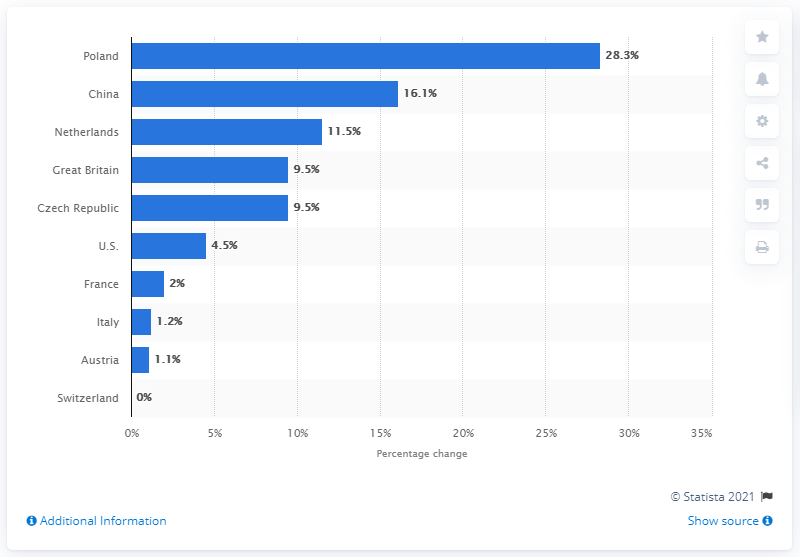List a handful of essential elements in this visual. In 2014, the year-on-year change in German electronics exports to the Netherlands was 11.5%. The year-on-year change in German electronics exports to the US and France in 2014 was 6.5%. 